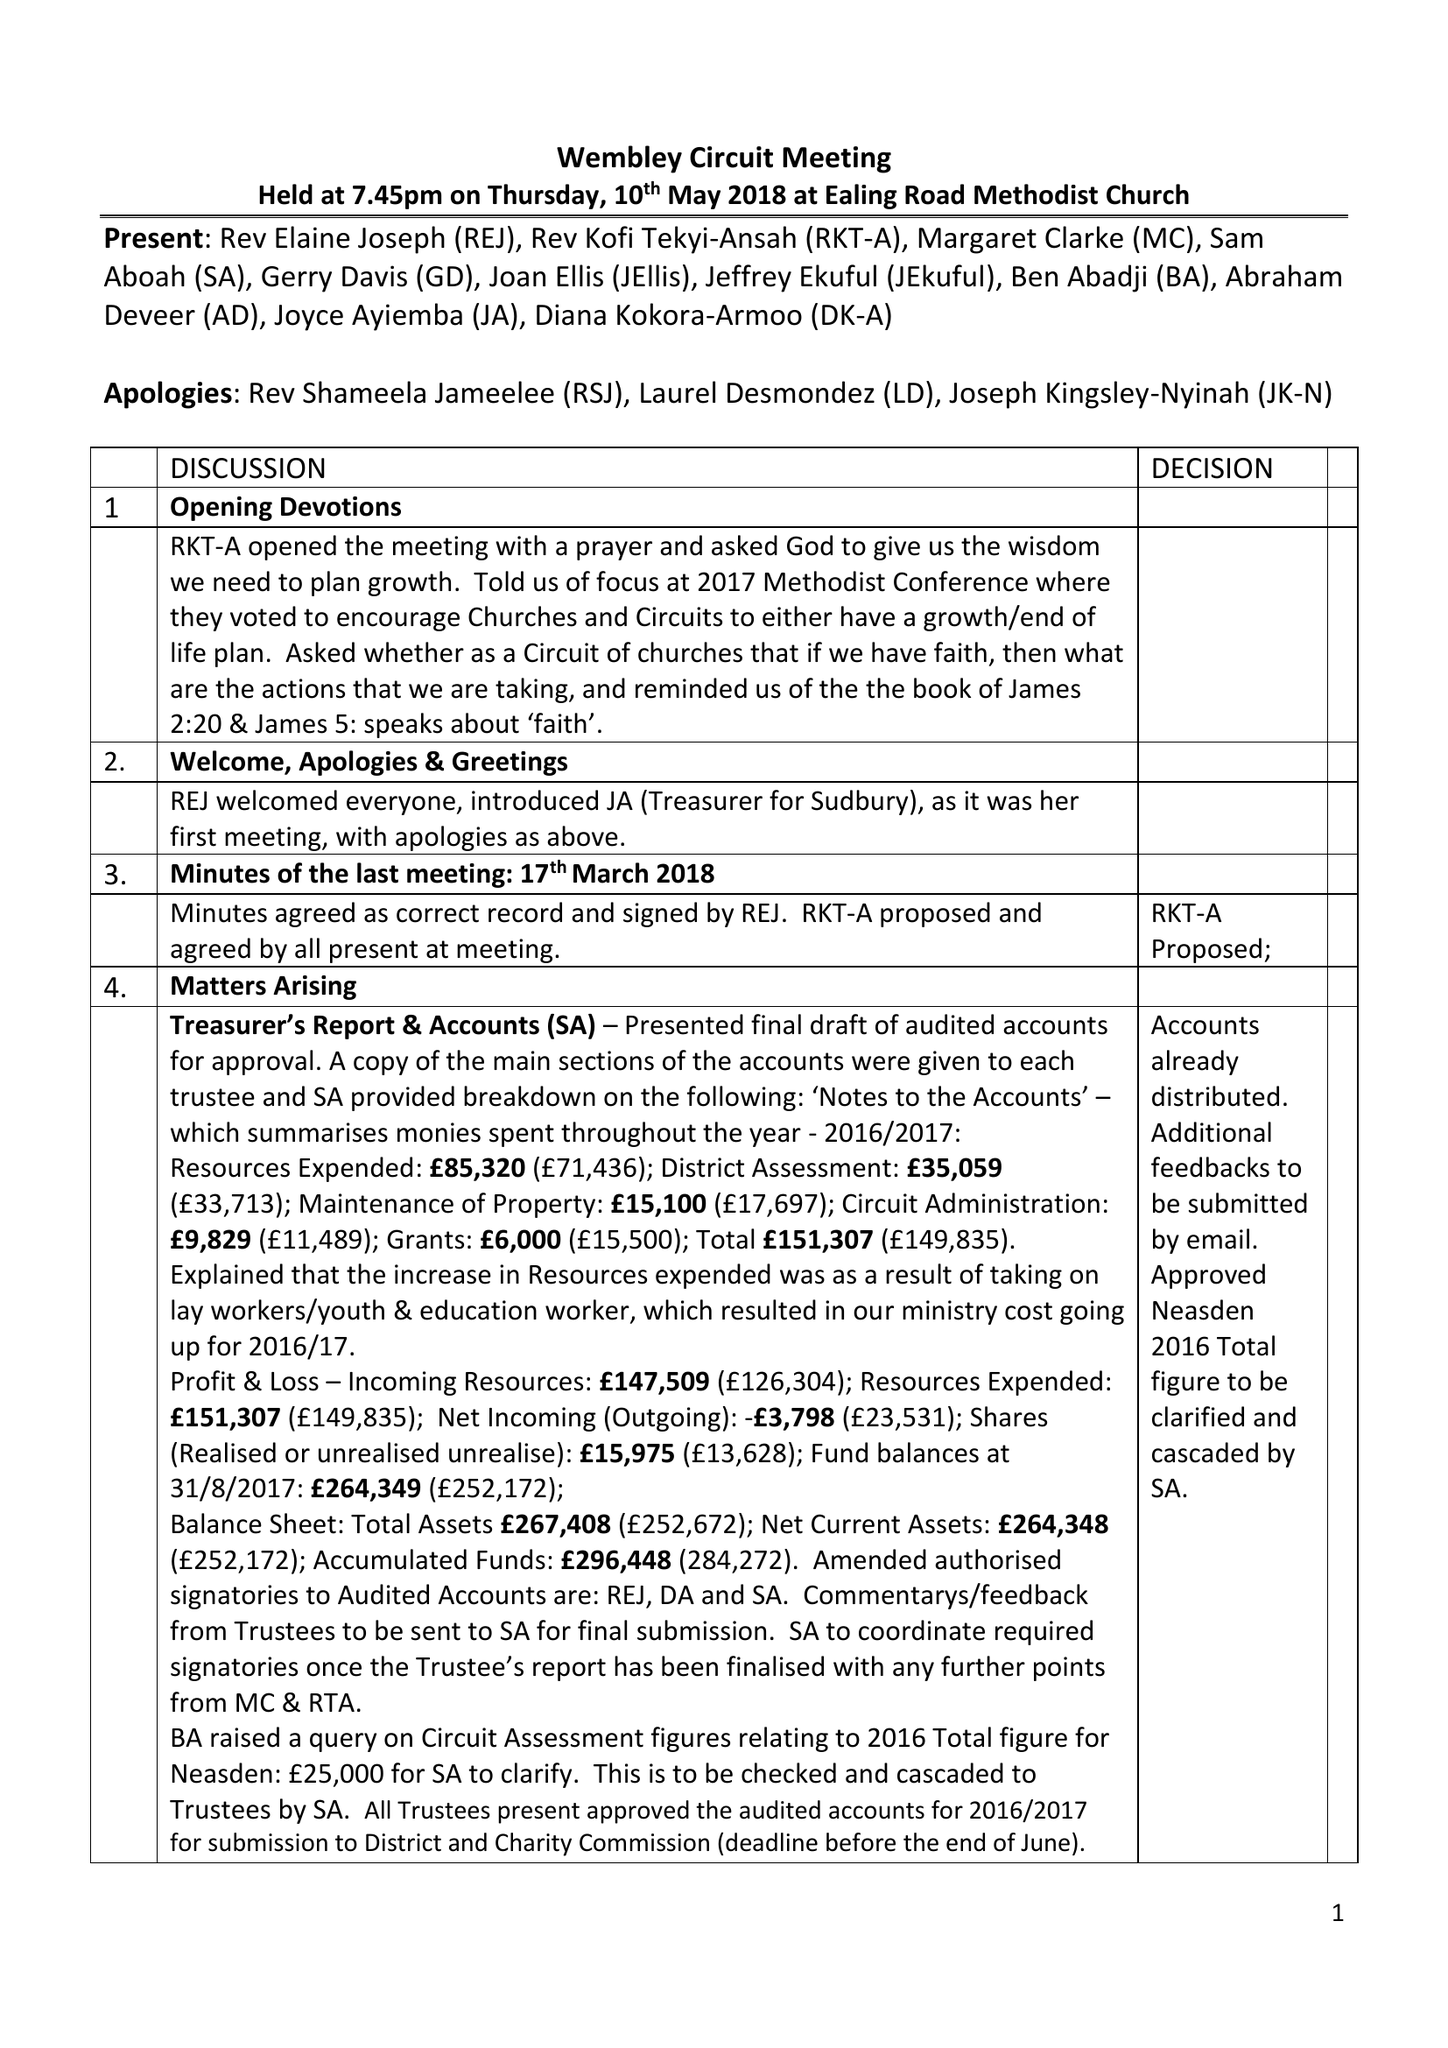What is the value for the charity_name?
Answer the question using a single word or phrase. Wembley Circuit Of The Methodist Church 